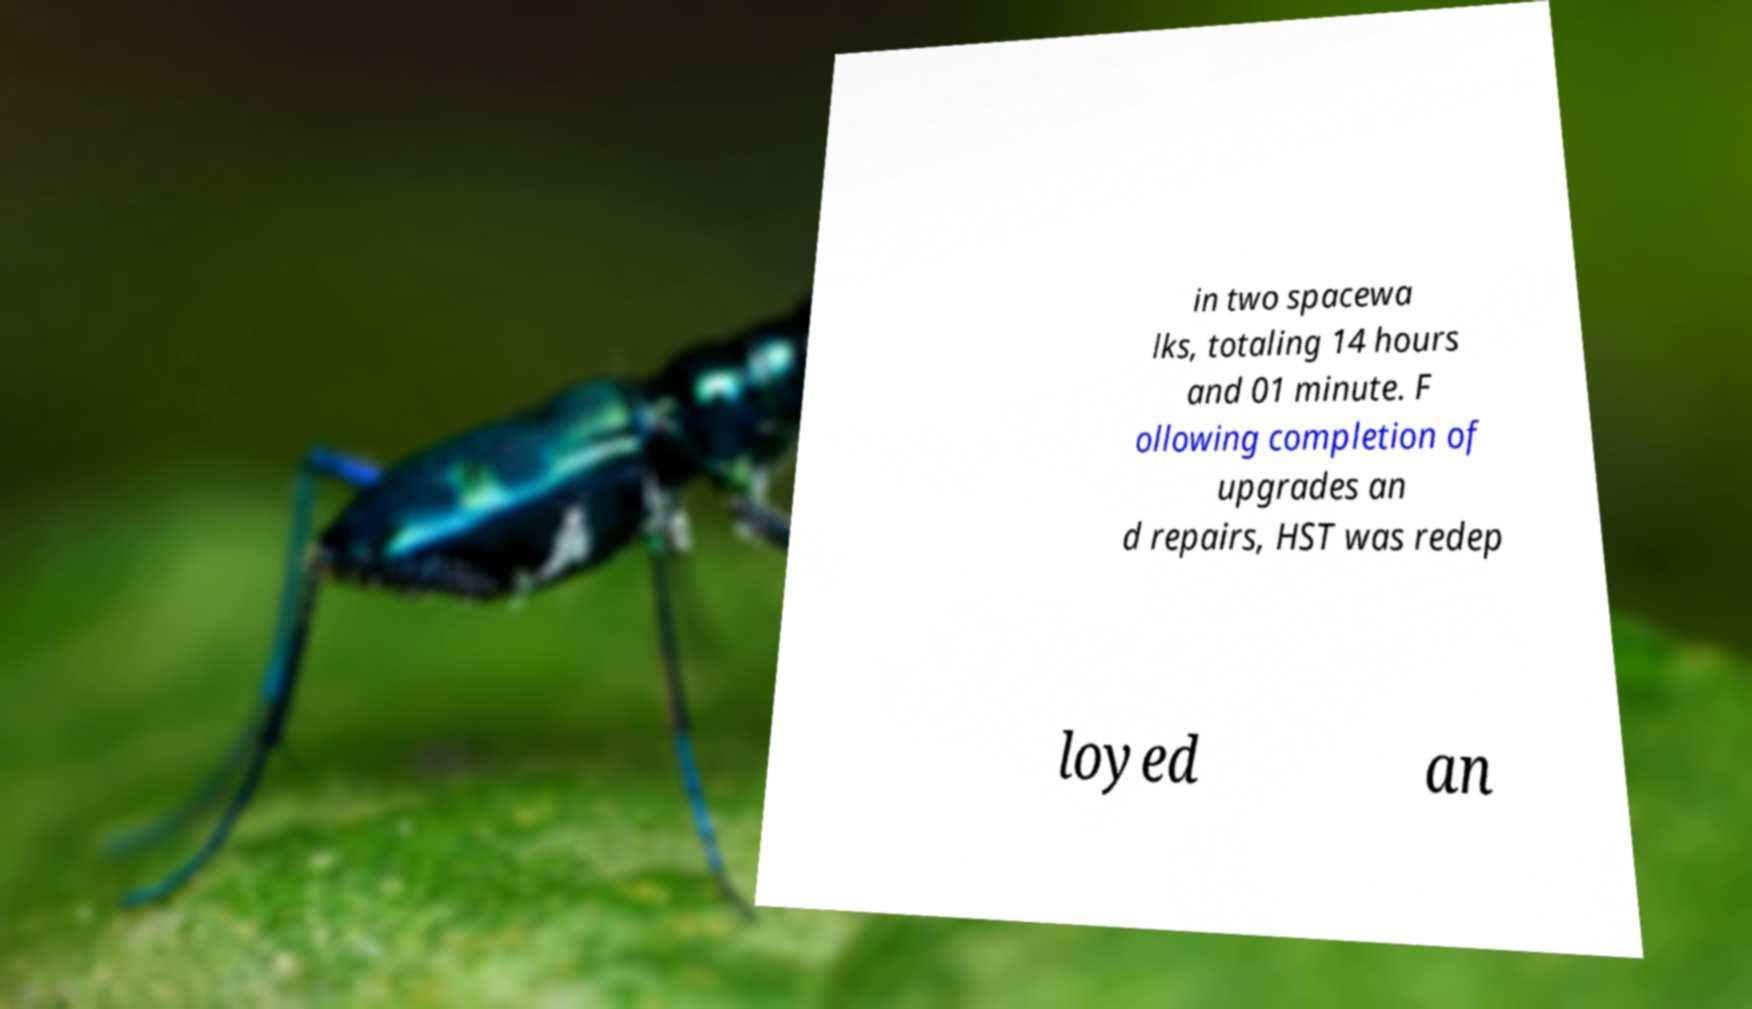I need the written content from this picture converted into text. Can you do that? in two spacewa lks, totaling 14 hours and 01 minute. F ollowing completion of upgrades an d repairs, HST was redep loyed an 